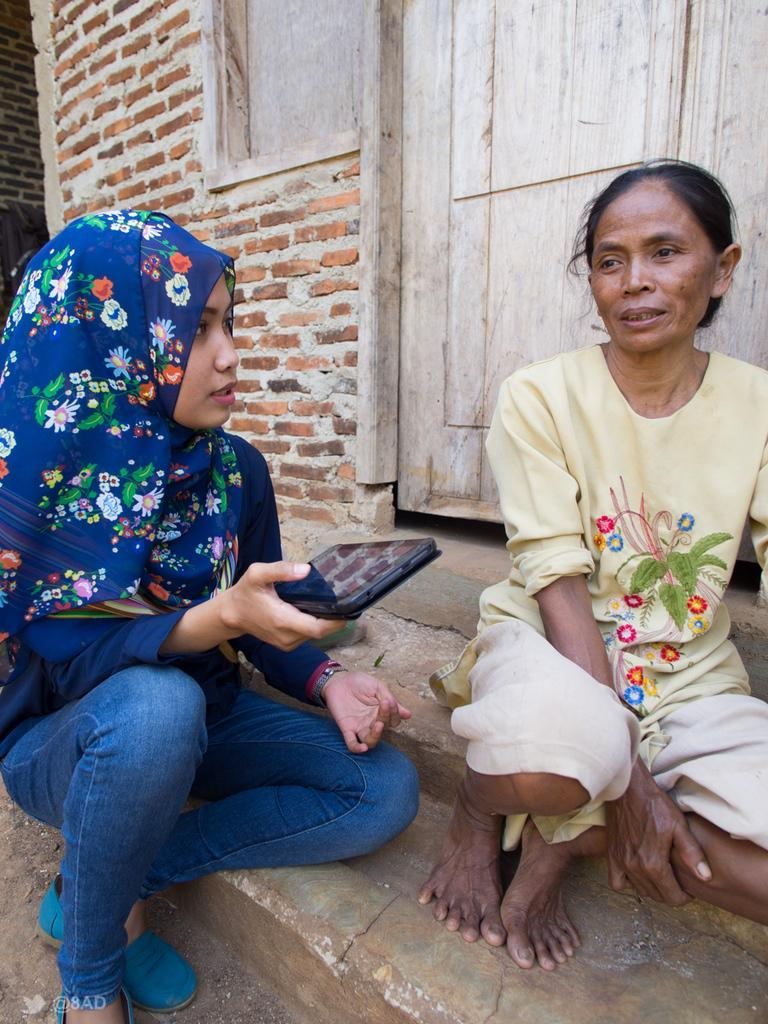How many women are in the image? There are two women in the image. What are the women doing in the image? The women are sitting on a surface. Can you describe what one of the women is holding? One of the women is holding a tab. What can be seen in the background of the image? There is a wall and a wooden door in the background of the image. What type of comb is the woman using to guide the building in the image? There is no comb or building present in the image. 